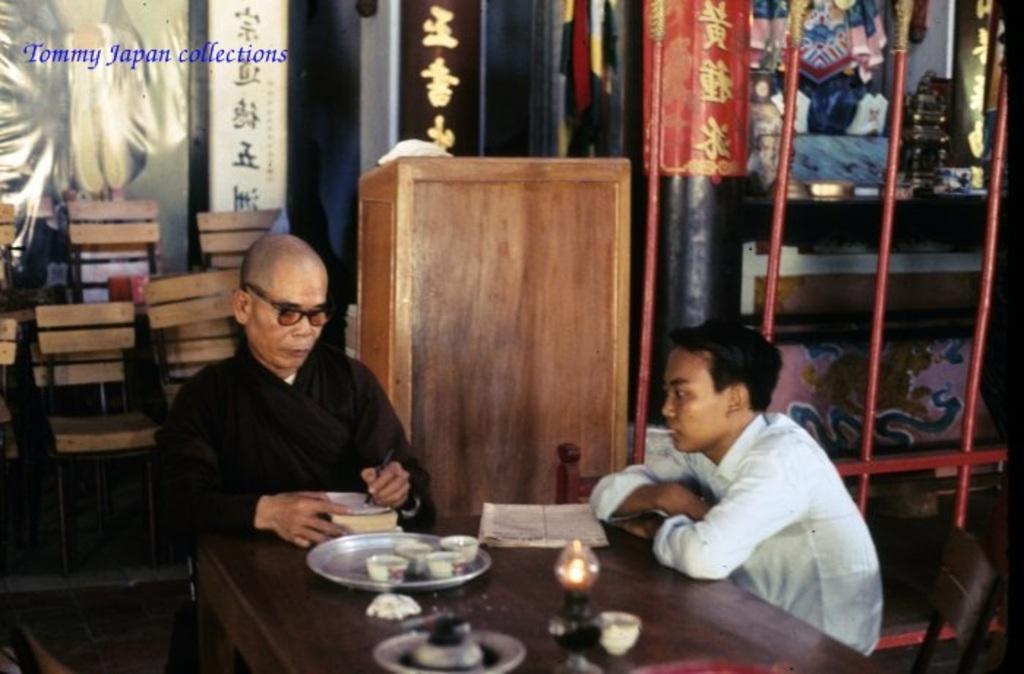Could you give a brief overview of what you see in this image? Here I can see two men are sitting on the chairs in front of the table. The man who is on the left side is wearing a black color dress, holding a pen in the hand and writing something on the book. The man who is on the right side is looking at the book. On the table, I can see a plate, tea cups, some papers and bowls. At the back of these people there is a cupboard. On the right side there is a rack in which few objects are filled. On the left side, I can see few empty chairs. On the top of the image I can see some text. 